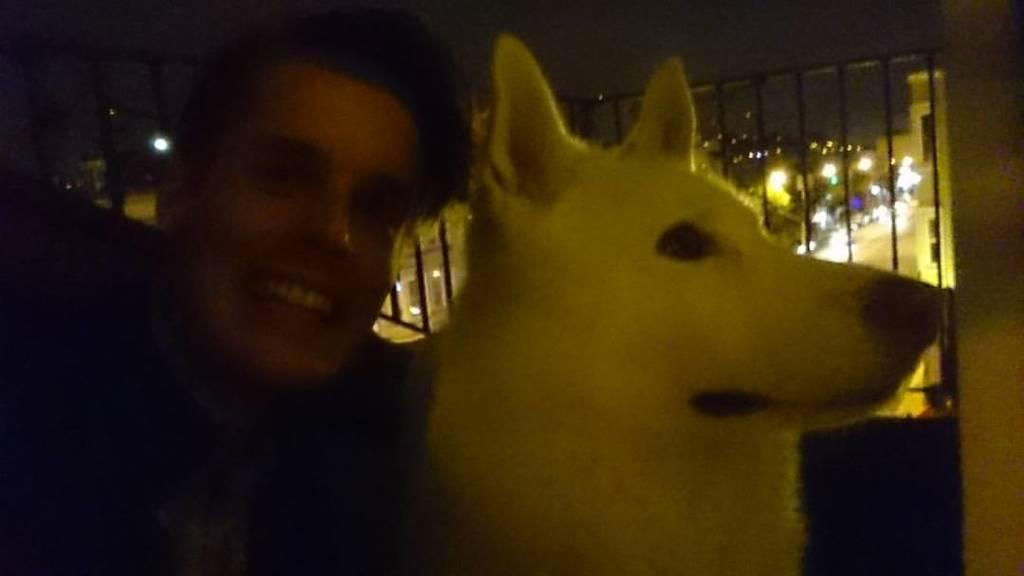Who or what is the main subject in the image? There is a person in the image. What is the person holding in the image? The person is holding a white-colored dog. What can be seen in the background of the image? There are lights visible in the background of the image. How is the person's expression in the image? The person is giving a smile to the camera. What type of plantation is visible in the image? There is no plantation present in the image. What is the purpose of the alarm in the image? There is no alarm present in the image. 